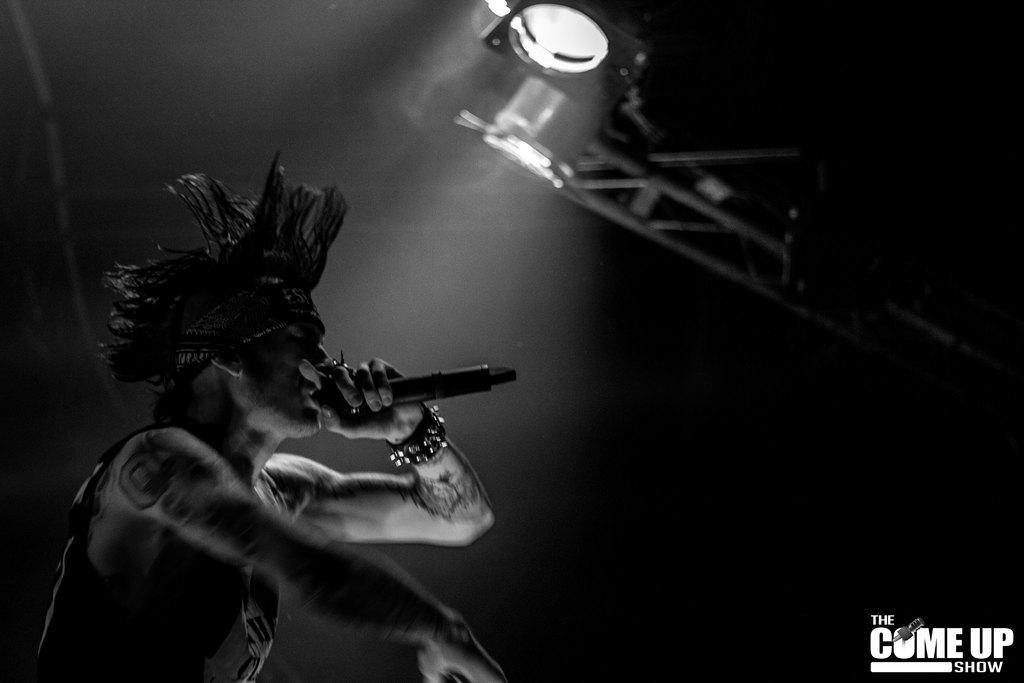In one or two sentences, can you explain what this image depicts? In this image we can see a person holding a mic. At the top we can see a light with a stand. In the bottom right we can see some text. 